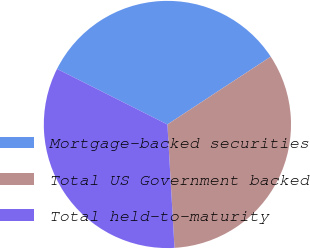Convert chart to OTSL. <chart><loc_0><loc_0><loc_500><loc_500><pie_chart><fcel>Mortgage-backed securities<fcel>Total US Government backed<fcel>Total held-to-maturity<nl><fcel>33.33%<fcel>33.33%<fcel>33.33%<nl></chart> 